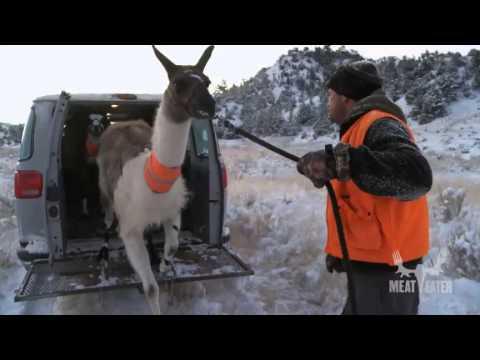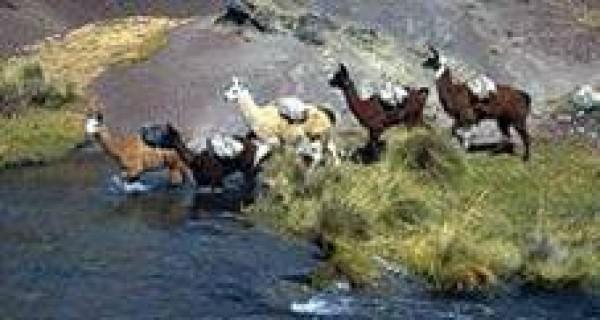The first image is the image on the left, the second image is the image on the right. Given the left and right images, does the statement "The left and right image contains the same number of llamas." hold true? Answer yes or no. No. The first image is the image on the left, the second image is the image on the right. Given the left and right images, does the statement "The left image contains a single llama and a single person." hold true? Answer yes or no. Yes. 